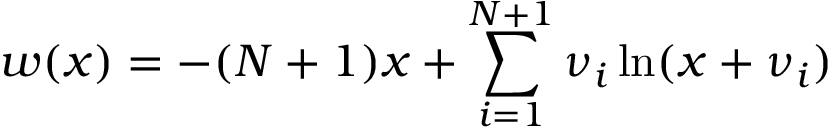<formula> <loc_0><loc_0><loc_500><loc_500>w ( x ) = - ( N + 1 ) x + \sum _ { i = 1 } ^ { N + 1 } \nu _ { i } \ln ( x + \nu _ { i } )</formula> 